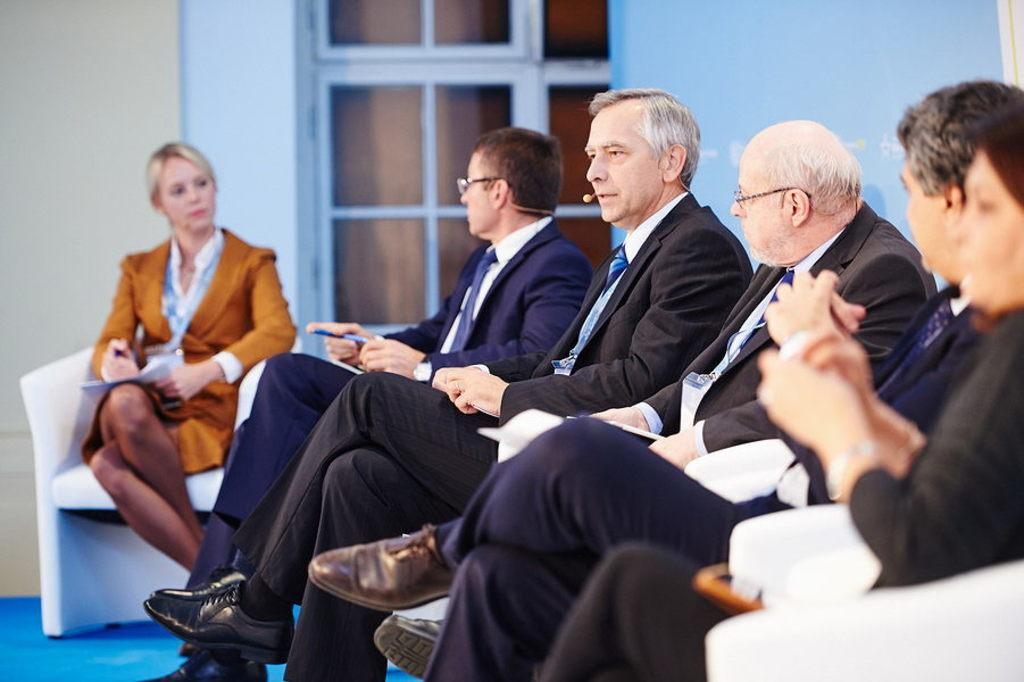How many people are in the image? There is a group of people in the image. What are the people doing in the image? The people are sitting on chairs. What is behind the group of people? There is a wall behind the group of people. Can you describe the wall in the image? There is a window in the wall. What unit of measurement is being used to write on the wall in the image? There is no writing on the wall in the image, so no unit of measurement is being used. 